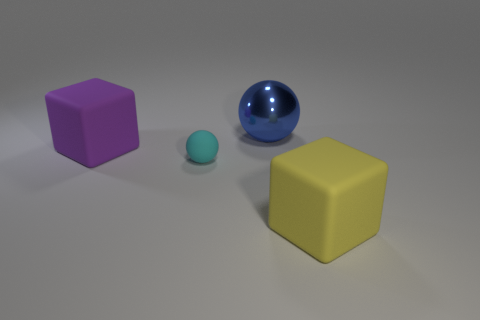Add 3 tiny matte objects. How many objects exist? 7 Add 1 large blue metallic spheres. How many large blue metallic spheres are left? 2 Add 3 large yellow matte blocks. How many large yellow matte blocks exist? 4 Subtract 0 green spheres. How many objects are left? 4 Subtract all large purple rubber blocks. Subtract all large cubes. How many objects are left? 1 